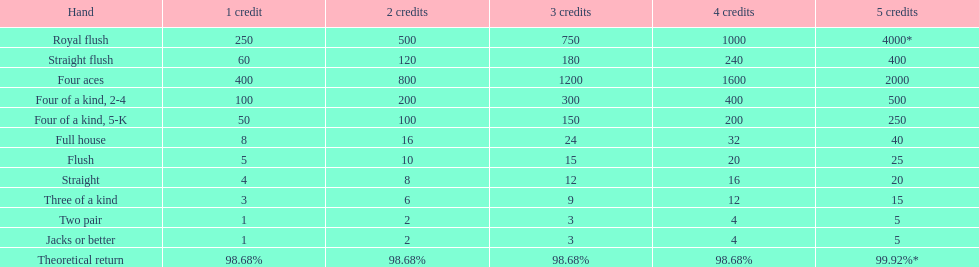Which holds a greater position: a straight or a flush? Flush. 